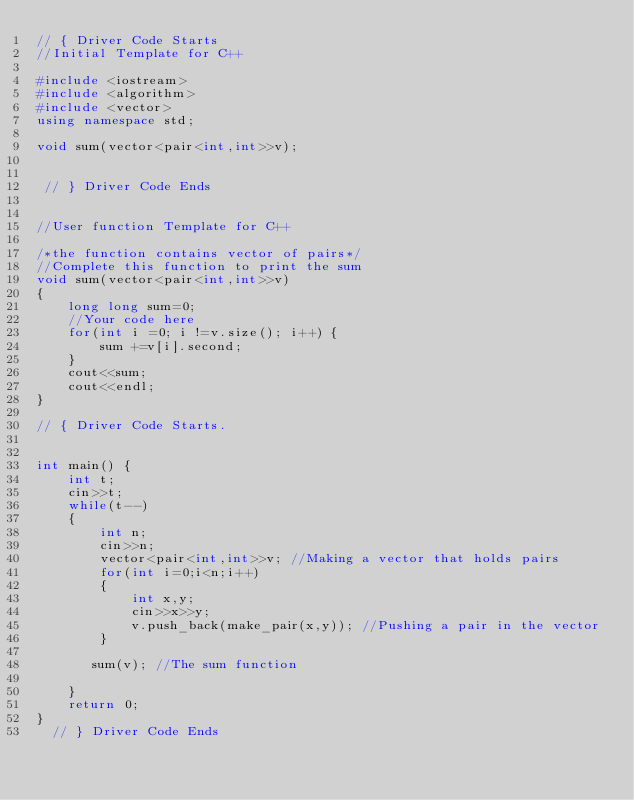Convert code to text. <code><loc_0><loc_0><loc_500><loc_500><_C++_>// { Driver Code Starts
//Initial Template for C++

#include <iostream>
#include <algorithm>
#include <vector>
using namespace std;

void sum(vector<pair<int,int>>v);


 // } Driver Code Ends


//User function Template for C++

/*the function contains vector of pairs*/
//Complete this function to print the sum
void sum(vector<pair<int,int>>v)
{
    long long sum=0;
    //Your code here
    for(int i =0; i !=v.size(); i++) {
        sum +=v[i].second;
    }
    cout<<sum;
    cout<<endl;
}

// { Driver Code Starts.


int main() {
	int t;
	cin>>t;
	while(t--)
	{
	    int n;
	    cin>>n;
	    vector<pair<int,int>>v; //Making a vector that holds pairs
	    for(int i=0;i<n;i++)
	    {
	        int x,y;
	        cin>>x>>y;
	        v.push_back(make_pair(x,y)); //Pushing a pair in the vector
	    } 
	    
	   sum(v); //The sum function
	   
	}
	return 0;
}
  // } Driver Code Ends</code> 